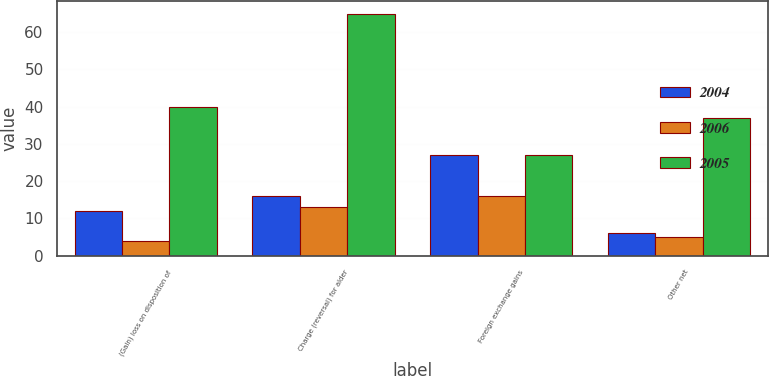<chart> <loc_0><loc_0><loc_500><loc_500><stacked_bar_chart><ecel><fcel>(Gain) loss on disposition of<fcel>Charge (reversal) for alder<fcel>Foreign exchange gains<fcel>Other net<nl><fcel>2004<fcel>12<fcel>16<fcel>27<fcel>6<nl><fcel>2006<fcel>4<fcel>13<fcel>16<fcel>5<nl><fcel>2005<fcel>40<fcel>65<fcel>27<fcel>37<nl></chart> 